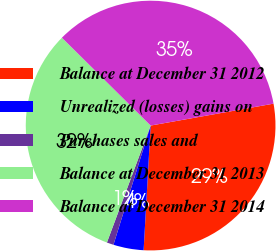Convert chart. <chart><loc_0><loc_0><loc_500><loc_500><pie_chart><fcel>Balance at December 31 2012<fcel>Unrealized (losses) gains on<fcel>Purchases sales and<fcel>Balance at December 31 2013<fcel>Balance at December 31 2014<nl><fcel>28.7%<fcel>3.92%<fcel>0.88%<fcel>31.73%<fcel>34.77%<nl></chart> 